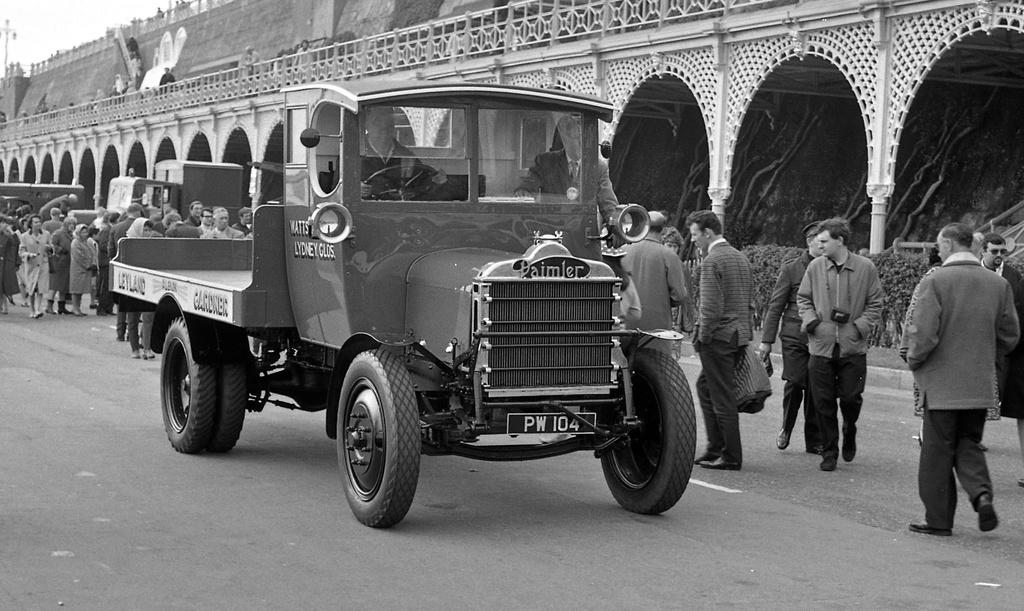Who or what can be seen in the image? There are people in the image. What else is present in the image besides people? There are vehicles on the road, a pole, a building, plants, and the sky is visible. Can you describe the vehicles in the image? The vehicles on the road are not specified, but they are present in the image. What type of plants are visible in the image? The plants in the image are not specified, but they are present. What type of foot can be seen on the pole in the image? There is no foot present on the pole in the image. 